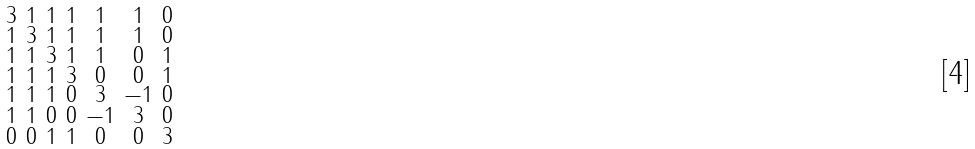Convert formula to latex. <formula><loc_0><loc_0><loc_500><loc_500>\begin{smallmatrix} 3 & 1 & 1 & 1 & 1 & 1 & 0 \\ 1 & 3 & 1 & 1 & 1 & 1 & 0 \\ 1 & 1 & 3 & 1 & 1 & 0 & 1 \\ 1 & 1 & 1 & 3 & 0 & 0 & 1 \\ 1 & 1 & 1 & 0 & 3 & - 1 & 0 \\ 1 & 1 & 0 & 0 & - 1 & 3 & 0 \\ 0 & 0 & 1 & 1 & 0 & 0 & 3 \end{smallmatrix}</formula> 